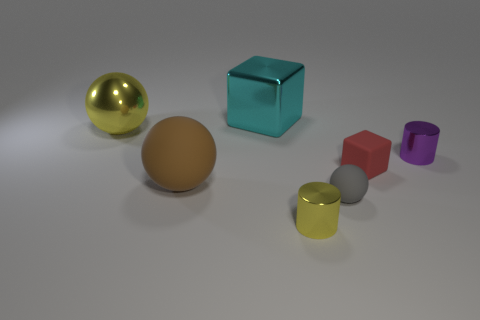Subtract all rubber spheres. How many spheres are left? 1 Add 2 big red shiny cylinders. How many objects exist? 9 Subtract all cubes. How many objects are left? 5 Subtract all big spheres. Subtract all big blocks. How many objects are left? 4 Add 6 cylinders. How many cylinders are left? 8 Add 4 small things. How many small things exist? 8 Subtract 1 brown spheres. How many objects are left? 6 